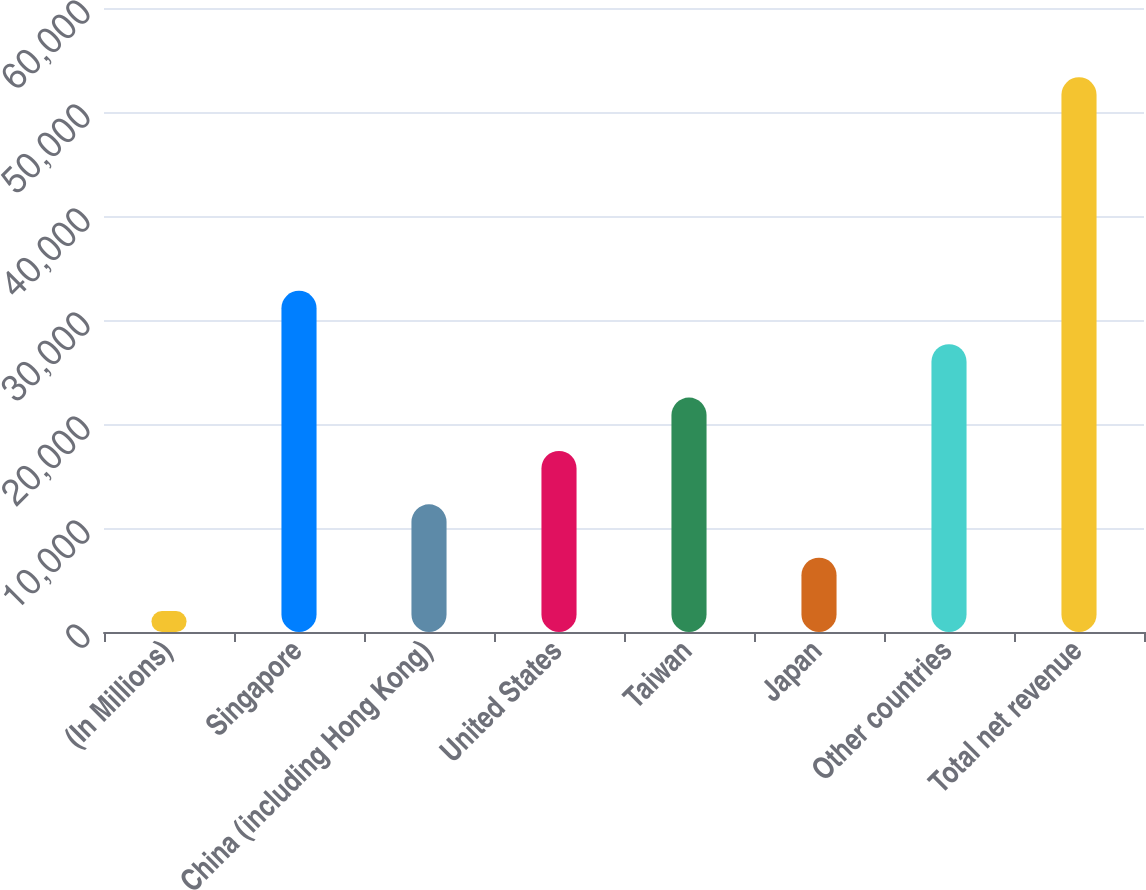Convert chart. <chart><loc_0><loc_0><loc_500><loc_500><bar_chart><fcel>(In Millions)<fcel>Singapore<fcel>China (including Hong Kong)<fcel>United States<fcel>Taiwan<fcel>Japan<fcel>Other countries<fcel>Total net revenue<nl><fcel>2012<fcel>32809.4<fcel>12277.8<fcel>17410.7<fcel>22543.6<fcel>7144.9<fcel>27676.5<fcel>53341<nl></chart> 